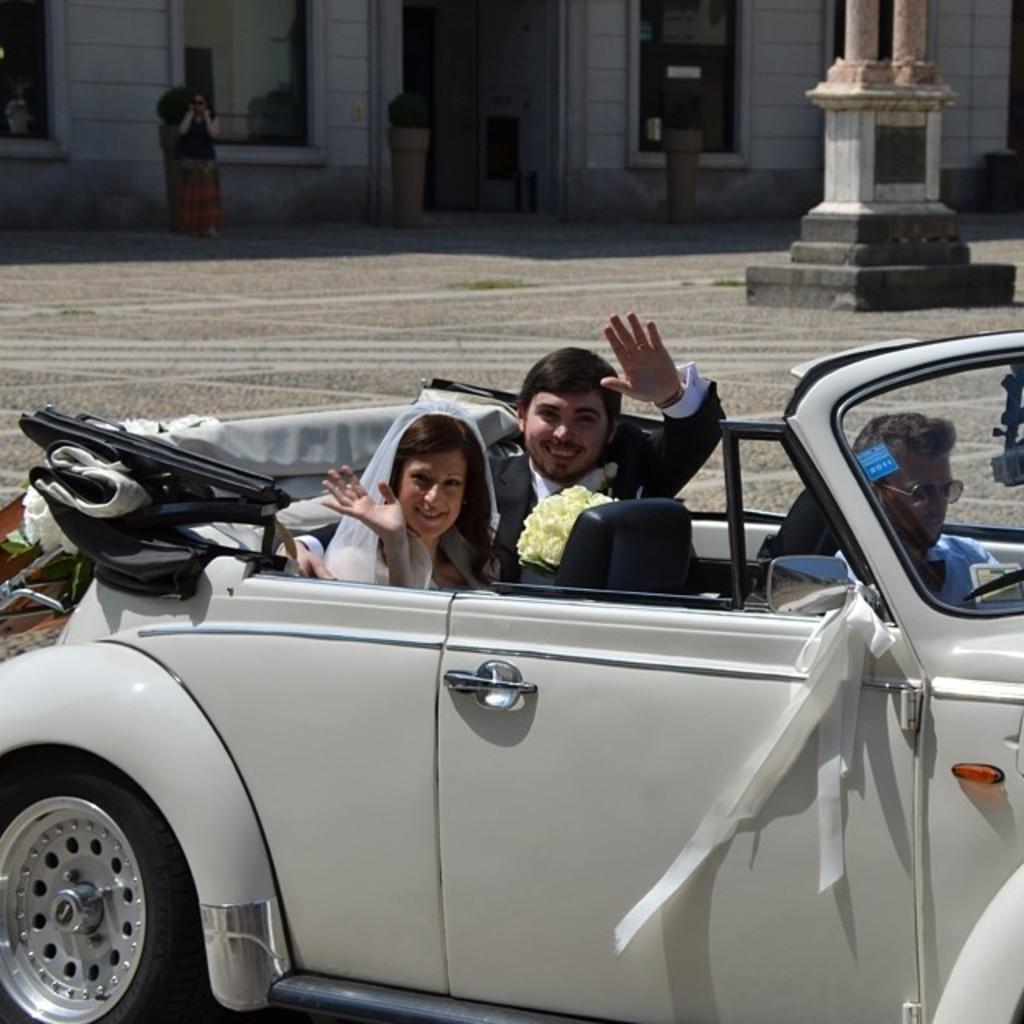Describe this image in one or two sentences. In this picture we can see man and woman sitting on car and they are smiling and in background we can see road, some woman, wall, window. 